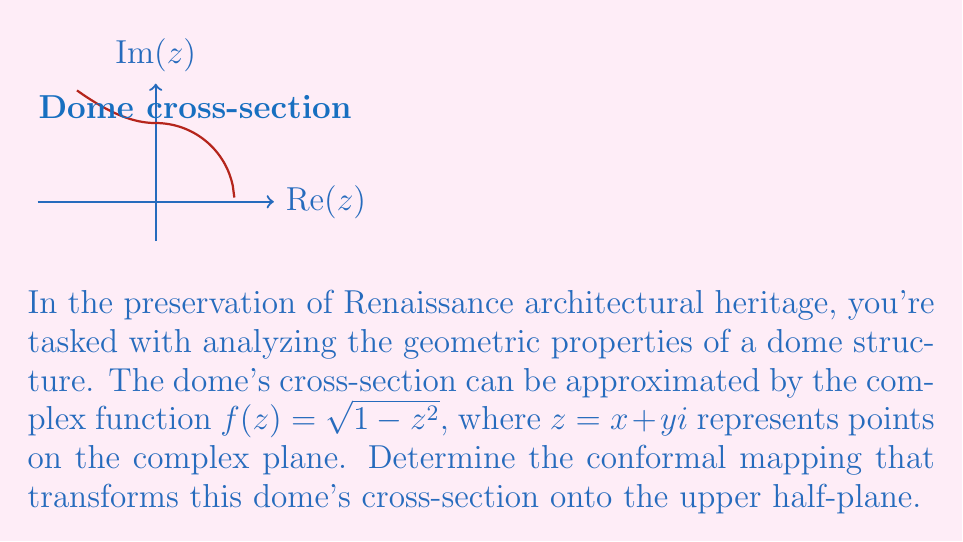Could you help me with this problem? To solve this problem, we'll follow these steps:

1) The given function $f(z) = \sqrt{1-z^2}$ represents a semicircle in the upper half-plane. We need to find a mapping that transforms this semicircle onto the real axis.

2) A well-known conformal mapping that takes the upper half-plane onto the unit disk is the Möbius transformation:

   $$w = \frac{z-i}{z+i}$$

3) The inverse of this transformation will map the unit disk onto the upper half-plane:

   $$z = i\frac{1+w}{1-w}$$

4) Our dome's cross-section is already a semicircle, similar to half of the unit disk. We just need to scale and shift it. The transformation $2z-1$ will map the interval $[0,1]$ to $[-1,1]$.

5) Combining these ideas, our conformal mapping will be:

   $$w = i\frac{1+(2z-1)}{1-(2z-1)} = i\frac{2z}{-2z+2} = \frac{z}{1-z}$$

6) This mapping will transform the semicircle (dome cross-section) in the z-plane to the real axis in the w-plane.

7) To verify, we can check the behavior at key points:
   - When $z = 0$, $w = 0$
   - When $z = 1$, $w = \infty$
   - When $z = -1$, $w = -\frac{1}{2}$

8) Points on the semicircle will be mapped to real values between $-\frac{1}{2}$ and $\infty$.
Answer: $w = \frac{z}{1-z}$ 